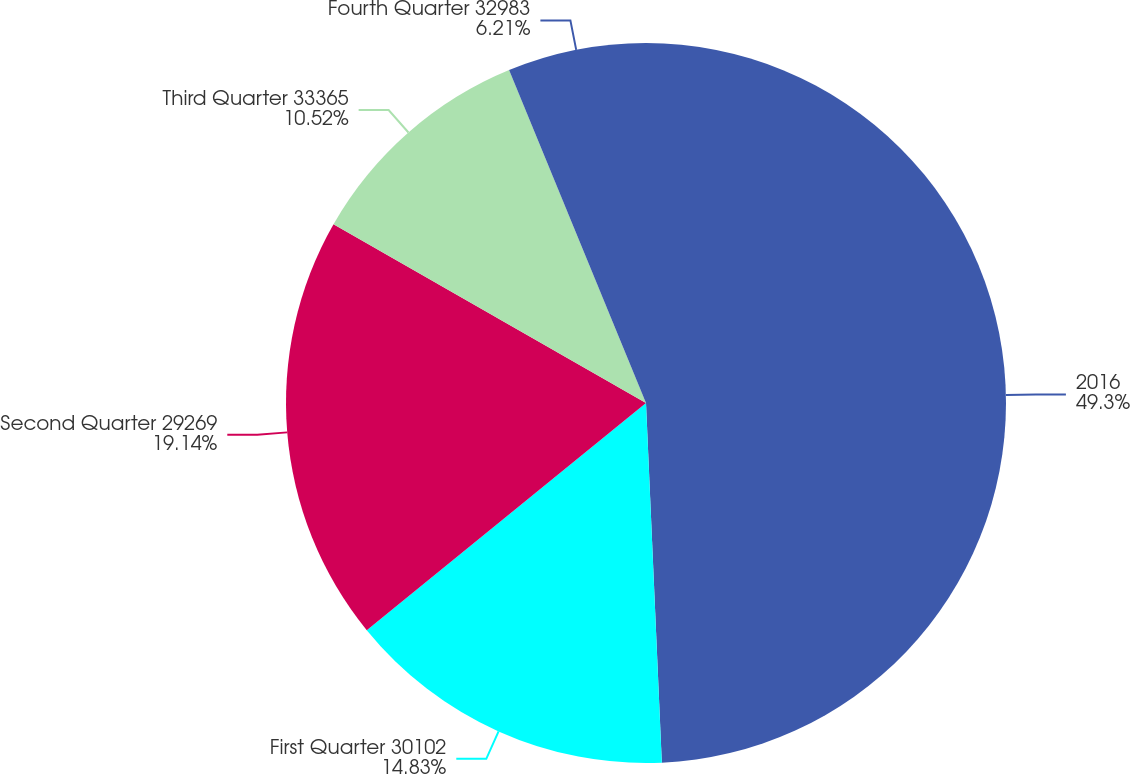Convert chart to OTSL. <chart><loc_0><loc_0><loc_500><loc_500><pie_chart><fcel>2016<fcel>First Quarter 30102<fcel>Second Quarter 29269<fcel>Third Quarter 33365<fcel>Fourth Quarter 32983<nl><fcel>49.3%<fcel>14.83%<fcel>19.14%<fcel>10.52%<fcel>6.21%<nl></chart> 